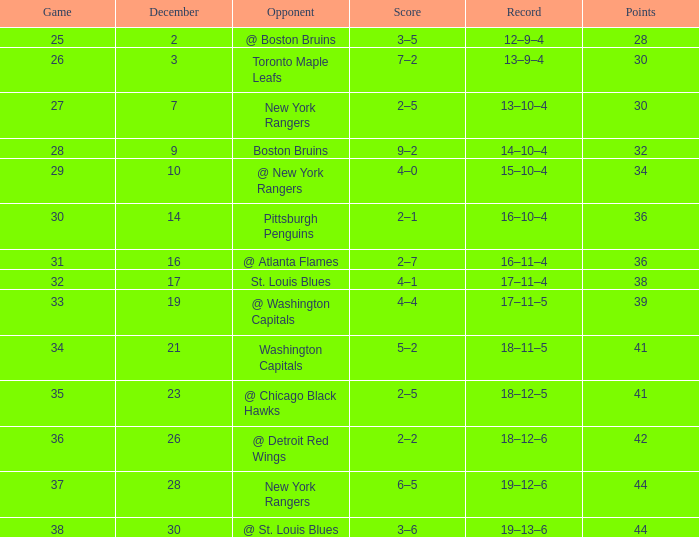Which Score has a Record of 18–11–5? 5–2. 